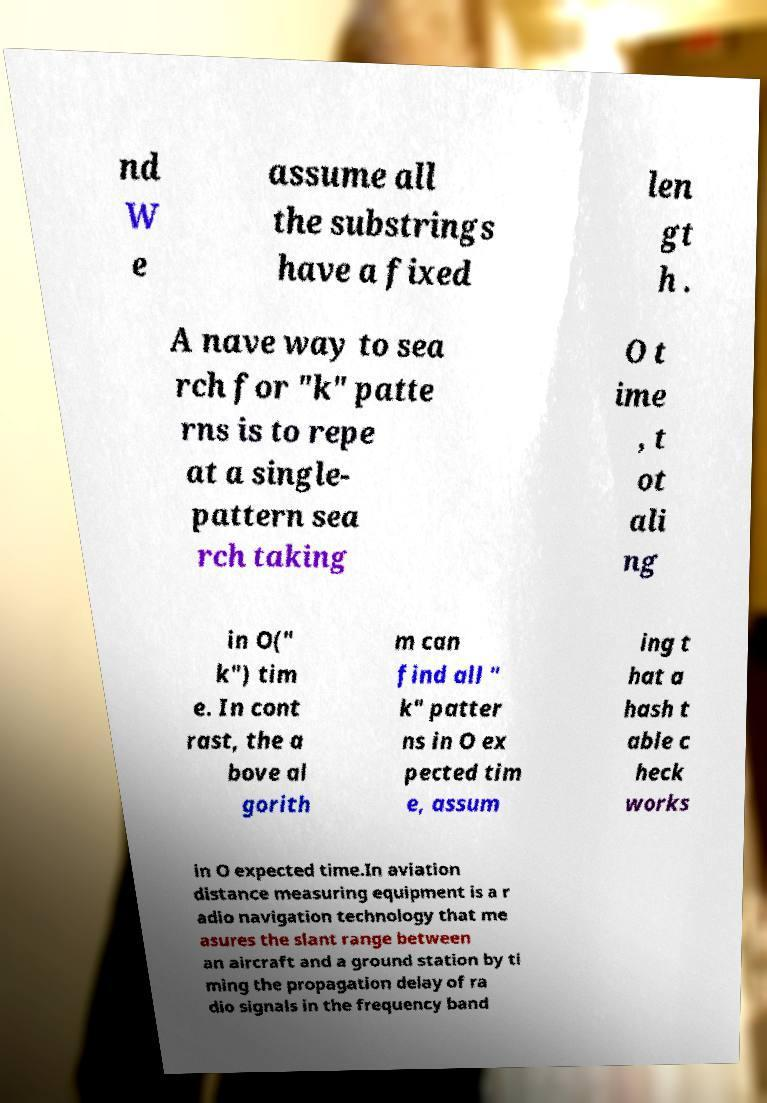There's text embedded in this image that I need extracted. Can you transcribe it verbatim? nd W e assume all the substrings have a fixed len gt h . A nave way to sea rch for "k" patte rns is to repe at a single- pattern sea rch taking O t ime , t ot ali ng in O(" k") tim e. In cont rast, the a bove al gorith m can find all " k" patter ns in O ex pected tim e, assum ing t hat a hash t able c heck works in O expected time.In aviation distance measuring equipment is a r adio navigation technology that me asures the slant range between an aircraft and a ground station by ti ming the propagation delay of ra dio signals in the frequency band 